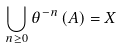<formula> <loc_0><loc_0><loc_500><loc_500>\bigcup _ { n \geq 0 } \theta ^ { - n } \left ( A \right ) = X</formula> 